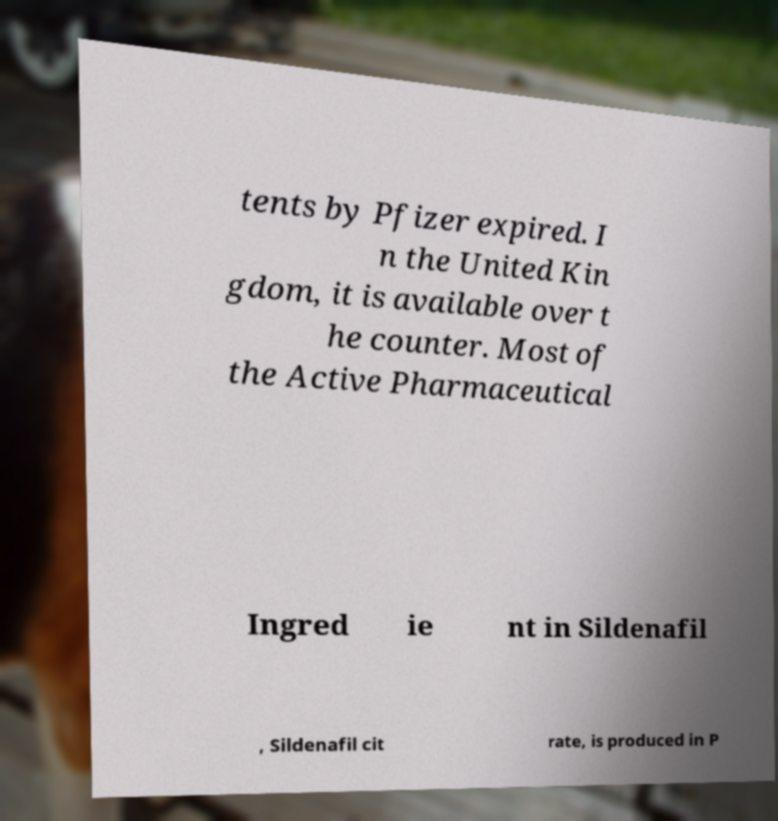Please identify and transcribe the text found in this image. tents by Pfizer expired. I n the United Kin gdom, it is available over t he counter. Most of the Active Pharmaceutical Ingred ie nt in Sildenafil , Sildenafil cit rate, is produced in P 